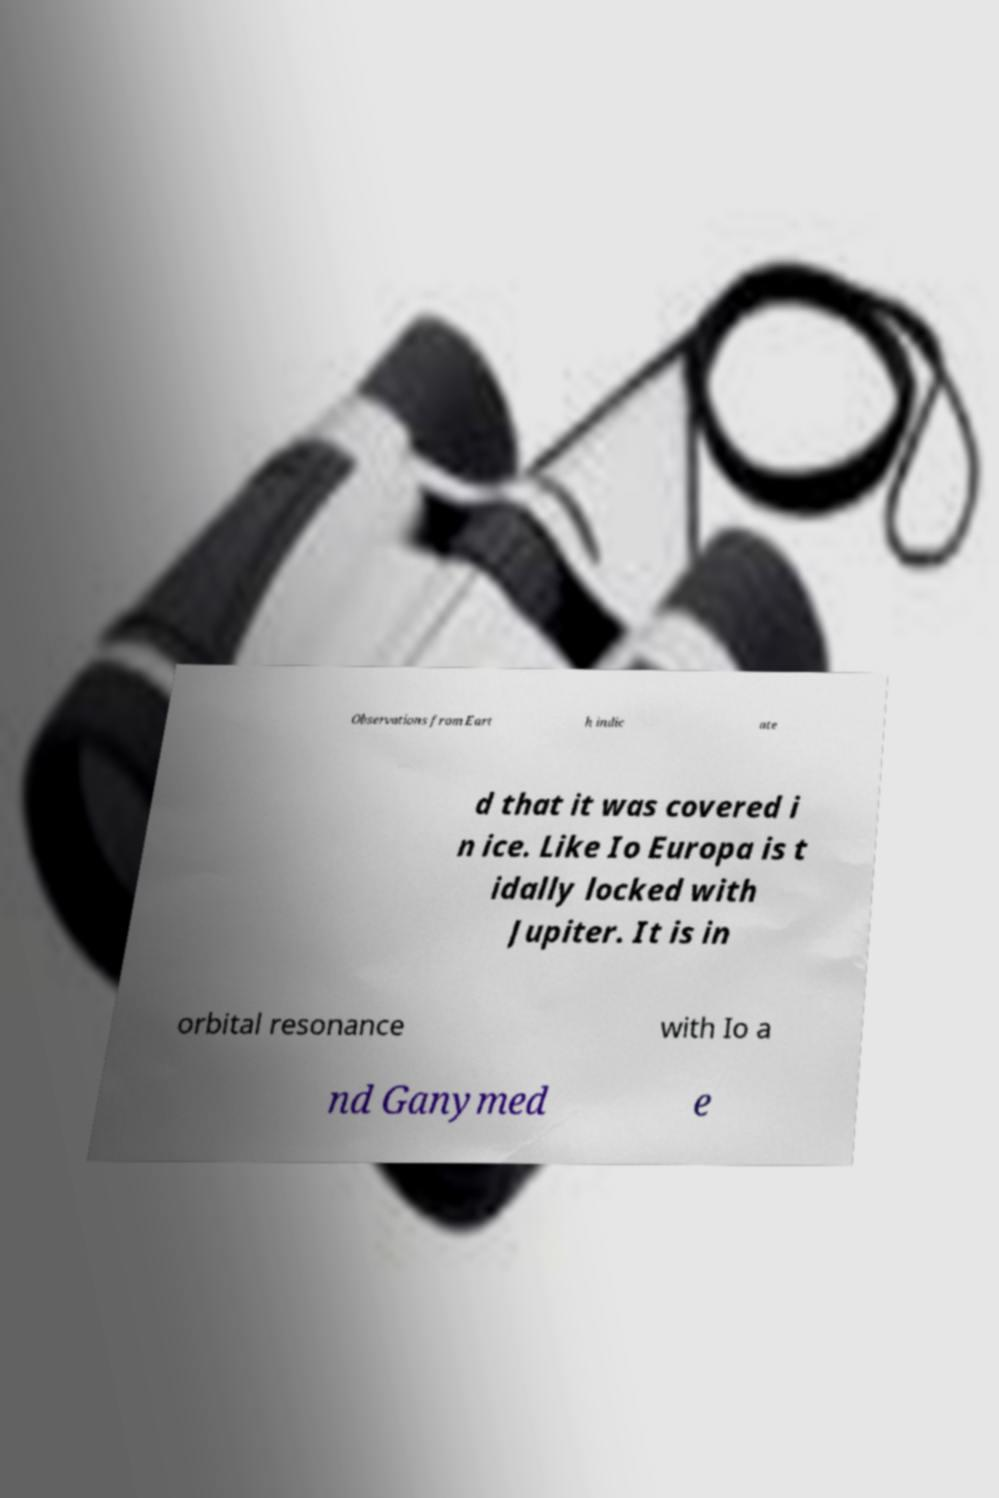Can you accurately transcribe the text from the provided image for me? Observations from Eart h indic ate d that it was covered i n ice. Like Io Europa is t idally locked with Jupiter. It is in orbital resonance with Io a nd Ganymed e 